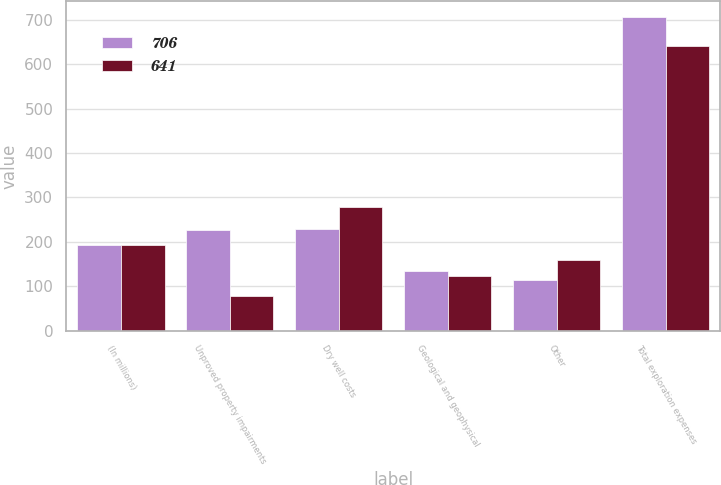Convert chart. <chart><loc_0><loc_0><loc_500><loc_500><stacked_bar_chart><ecel><fcel>(In millions)<fcel>Unproved property impairments<fcel>Dry well costs<fcel>Geological and geophysical<fcel>Other<fcel>Total exploration expenses<nl><fcel>706<fcel>193.5<fcel>227<fcel>230<fcel>135<fcel>114<fcel>706<nl><fcel>641<fcel>193.5<fcel>79<fcel>278<fcel>124<fcel>160<fcel>641<nl></chart> 